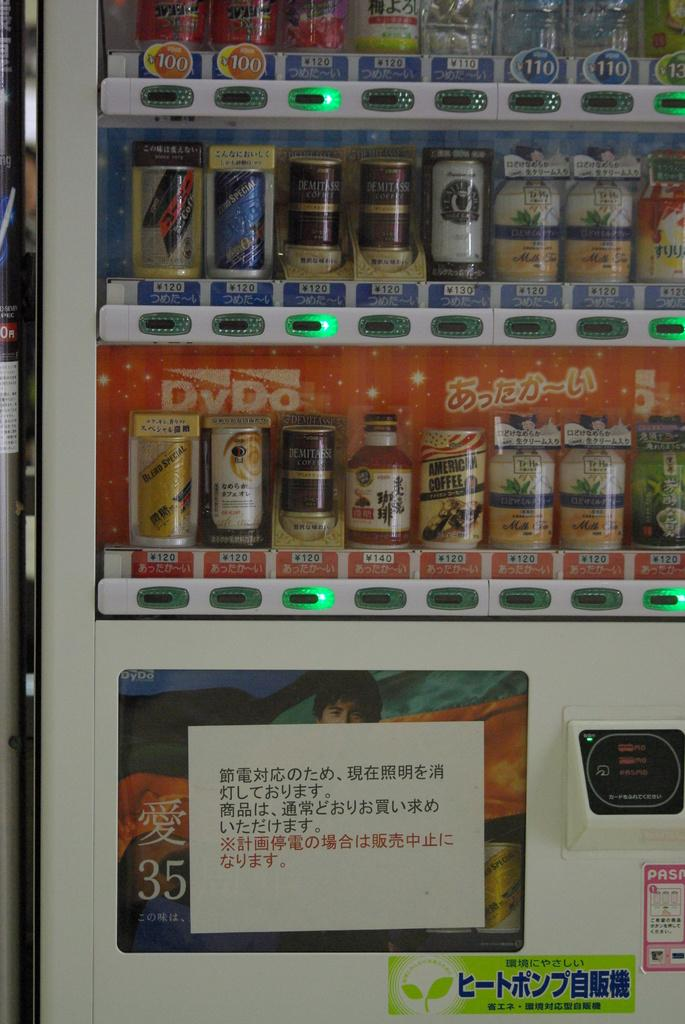<image>
Describe the image concisely. Many cans, including American Coffee and Demitassee Coffee, sit in a refrigerator 